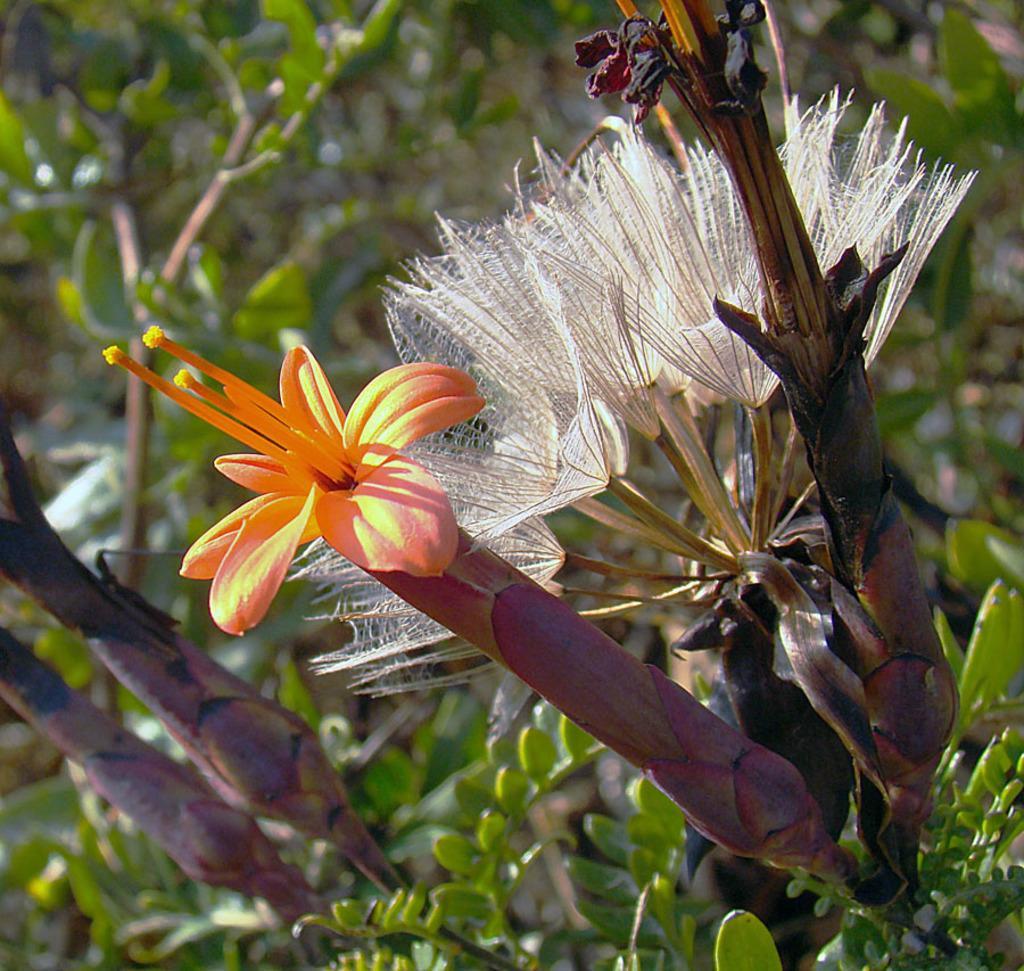How would you summarize this image in a sentence or two? In this image we can see flowers, plants, and the background is blurred. 